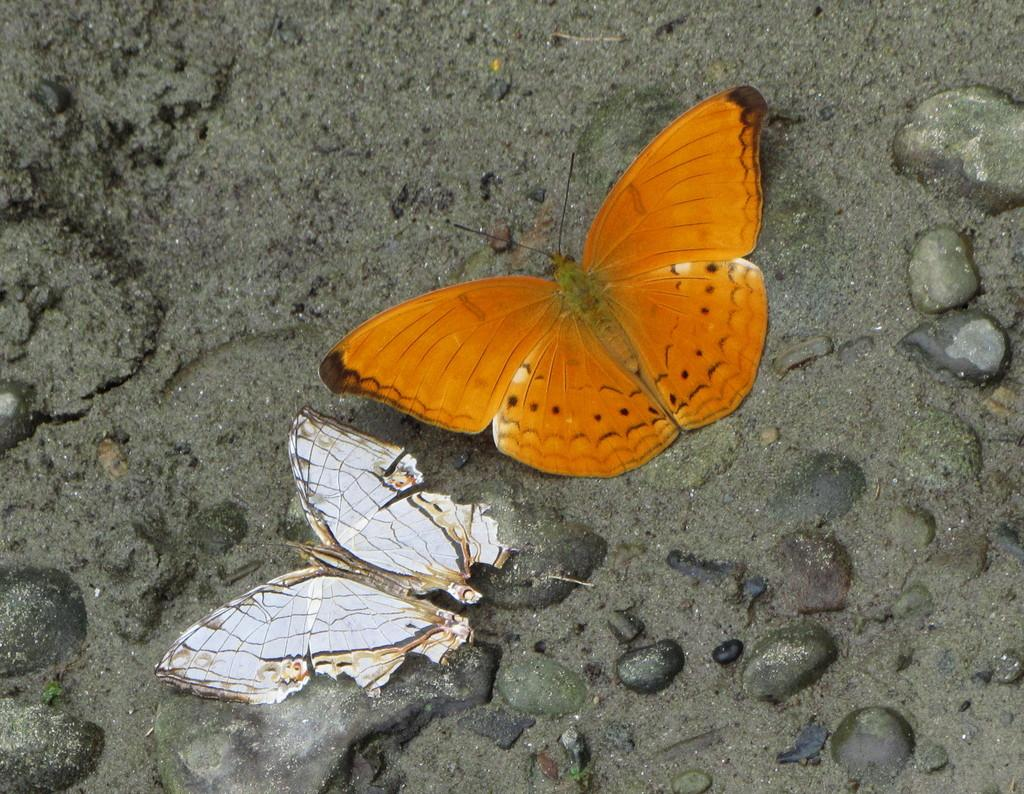What type of animals can be seen on the ground in the image? There are butterflies on the ground in the image. What other objects or features can be seen in the image? There are stones in the image. What type of music can be heard playing in the background of the image? There is no music present in the image, as it is a still photograph. 